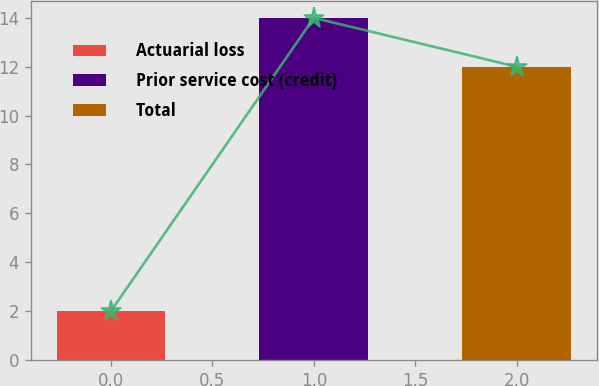<chart> <loc_0><loc_0><loc_500><loc_500><bar_chart><fcel>Actuarial loss<fcel>Prior service cost (credit)<fcel>Total<nl><fcel>2<fcel>14<fcel>12<nl></chart> 